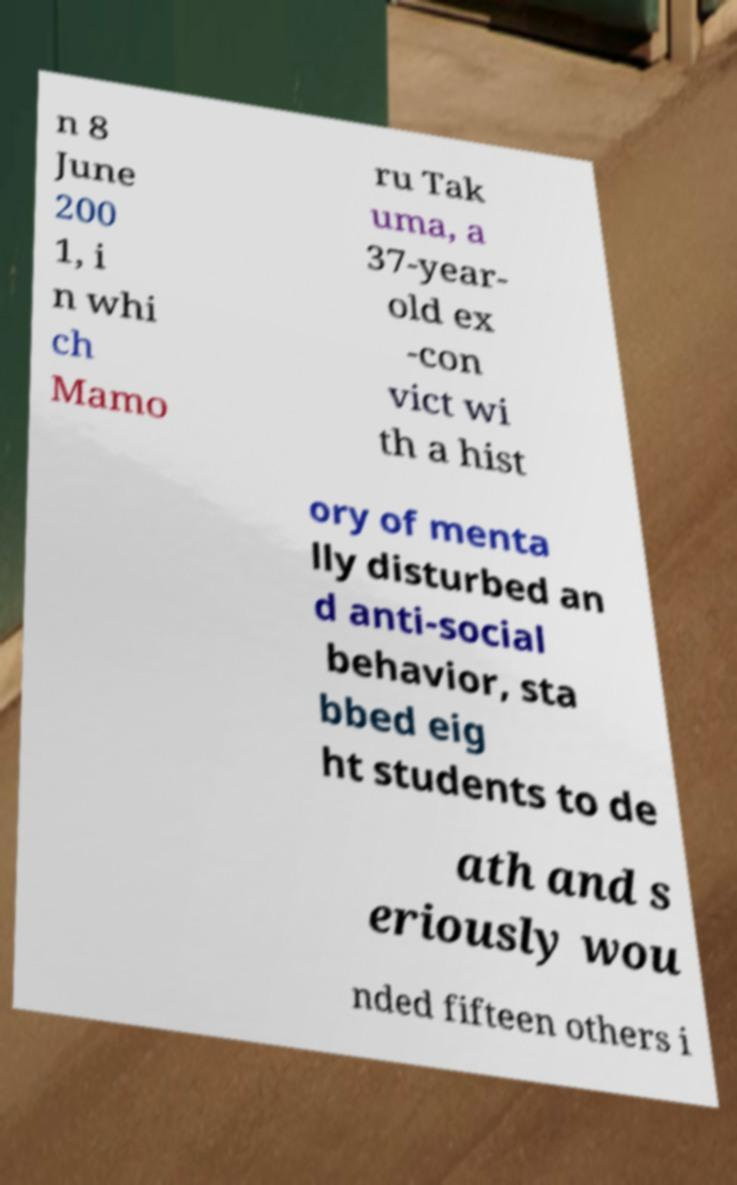Can you accurately transcribe the text from the provided image for me? n 8 June 200 1, i n whi ch Mamo ru Tak uma, a 37-year- old ex -con vict wi th a hist ory of menta lly disturbed an d anti-social behavior, sta bbed eig ht students to de ath and s eriously wou nded fifteen others i 